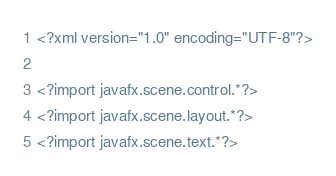<code> <loc_0><loc_0><loc_500><loc_500><_XML_><?xml version="1.0" encoding="UTF-8"?>

<?import javafx.scene.control.*?>
<?import javafx.scene.layout.*?>
<?import javafx.scene.text.*?>
</code> 